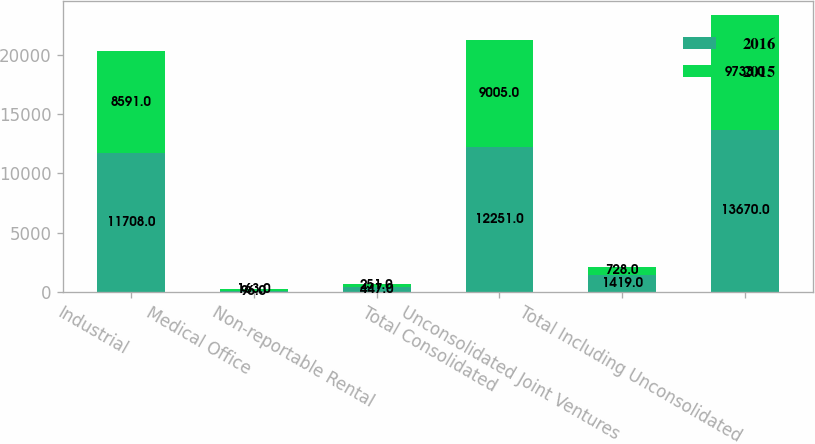Convert chart to OTSL. <chart><loc_0><loc_0><loc_500><loc_500><stacked_bar_chart><ecel><fcel>Industrial<fcel>Medical Office<fcel>Non-reportable Rental<fcel>Total Consolidated<fcel>Unconsolidated Joint Ventures<fcel>Total Including Unconsolidated<nl><fcel>2016<fcel>11708<fcel>96<fcel>447<fcel>12251<fcel>1419<fcel>13670<nl><fcel>2015<fcel>8591<fcel>163<fcel>251<fcel>9005<fcel>728<fcel>9733<nl></chart> 